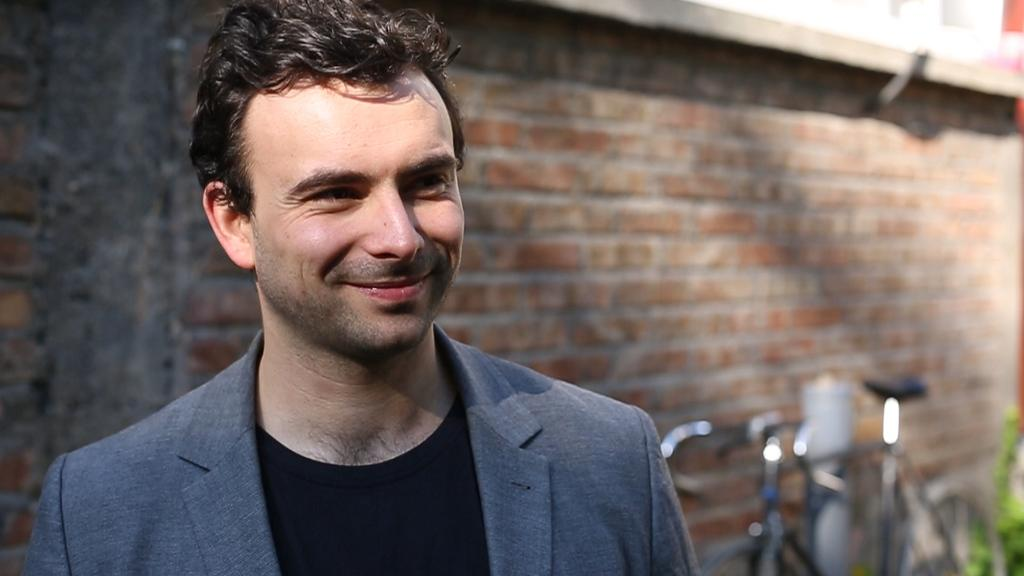Who or what is present in the image? There is a person in the image. What can be seen in the background of the image? There is a wall visible in the image. What object is also present in the image? There is a bicycle in the image. What type of advice can be seen written on the wall in the image? There is no advice visible on the wall in the image; only the wall itself is mentioned. 